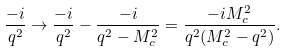<formula> <loc_0><loc_0><loc_500><loc_500>\frac { - i } { q ^ { 2 } } \rightarrow \frac { - i } { q ^ { 2 } } - \frac { - i } { q ^ { 2 } - M _ { c } ^ { 2 } } = \frac { - i M _ { c } ^ { 2 } } { q ^ { 2 } ( M _ { c } ^ { 2 } - q ^ { 2 } ) } .</formula> 